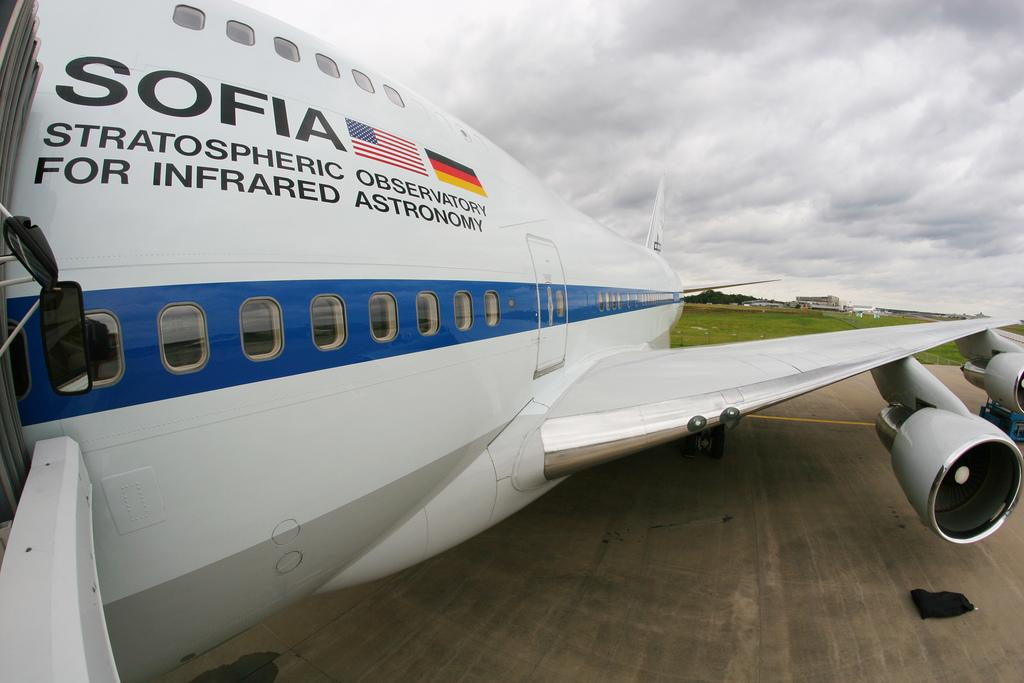<image>
Render a clear and concise summary of the photo. The jet clearly stated it's use for SOFIA, Stratospheric Observatory For Infrared Astronomy. 